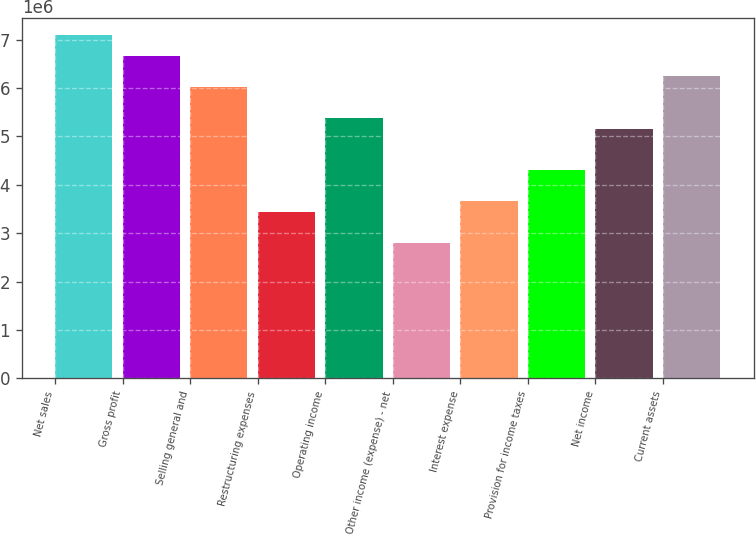Convert chart to OTSL. <chart><loc_0><loc_0><loc_500><loc_500><bar_chart><fcel>Net sales<fcel>Gross profit<fcel>Selling general and<fcel>Restructuring expenses<fcel>Operating income<fcel>Other income (expense) - net<fcel>Interest expense<fcel>Provision for income taxes<fcel>Net income<fcel>Current assets<nl><fcel>7.10094e+06<fcel>6.67058e+06<fcel>6.02504e+06<fcel>3.44288e+06<fcel>5.3795e+06<fcel>2.79734e+06<fcel>3.65806e+06<fcel>4.3036e+06<fcel>5.16432e+06<fcel>6.24022e+06<nl></chart> 